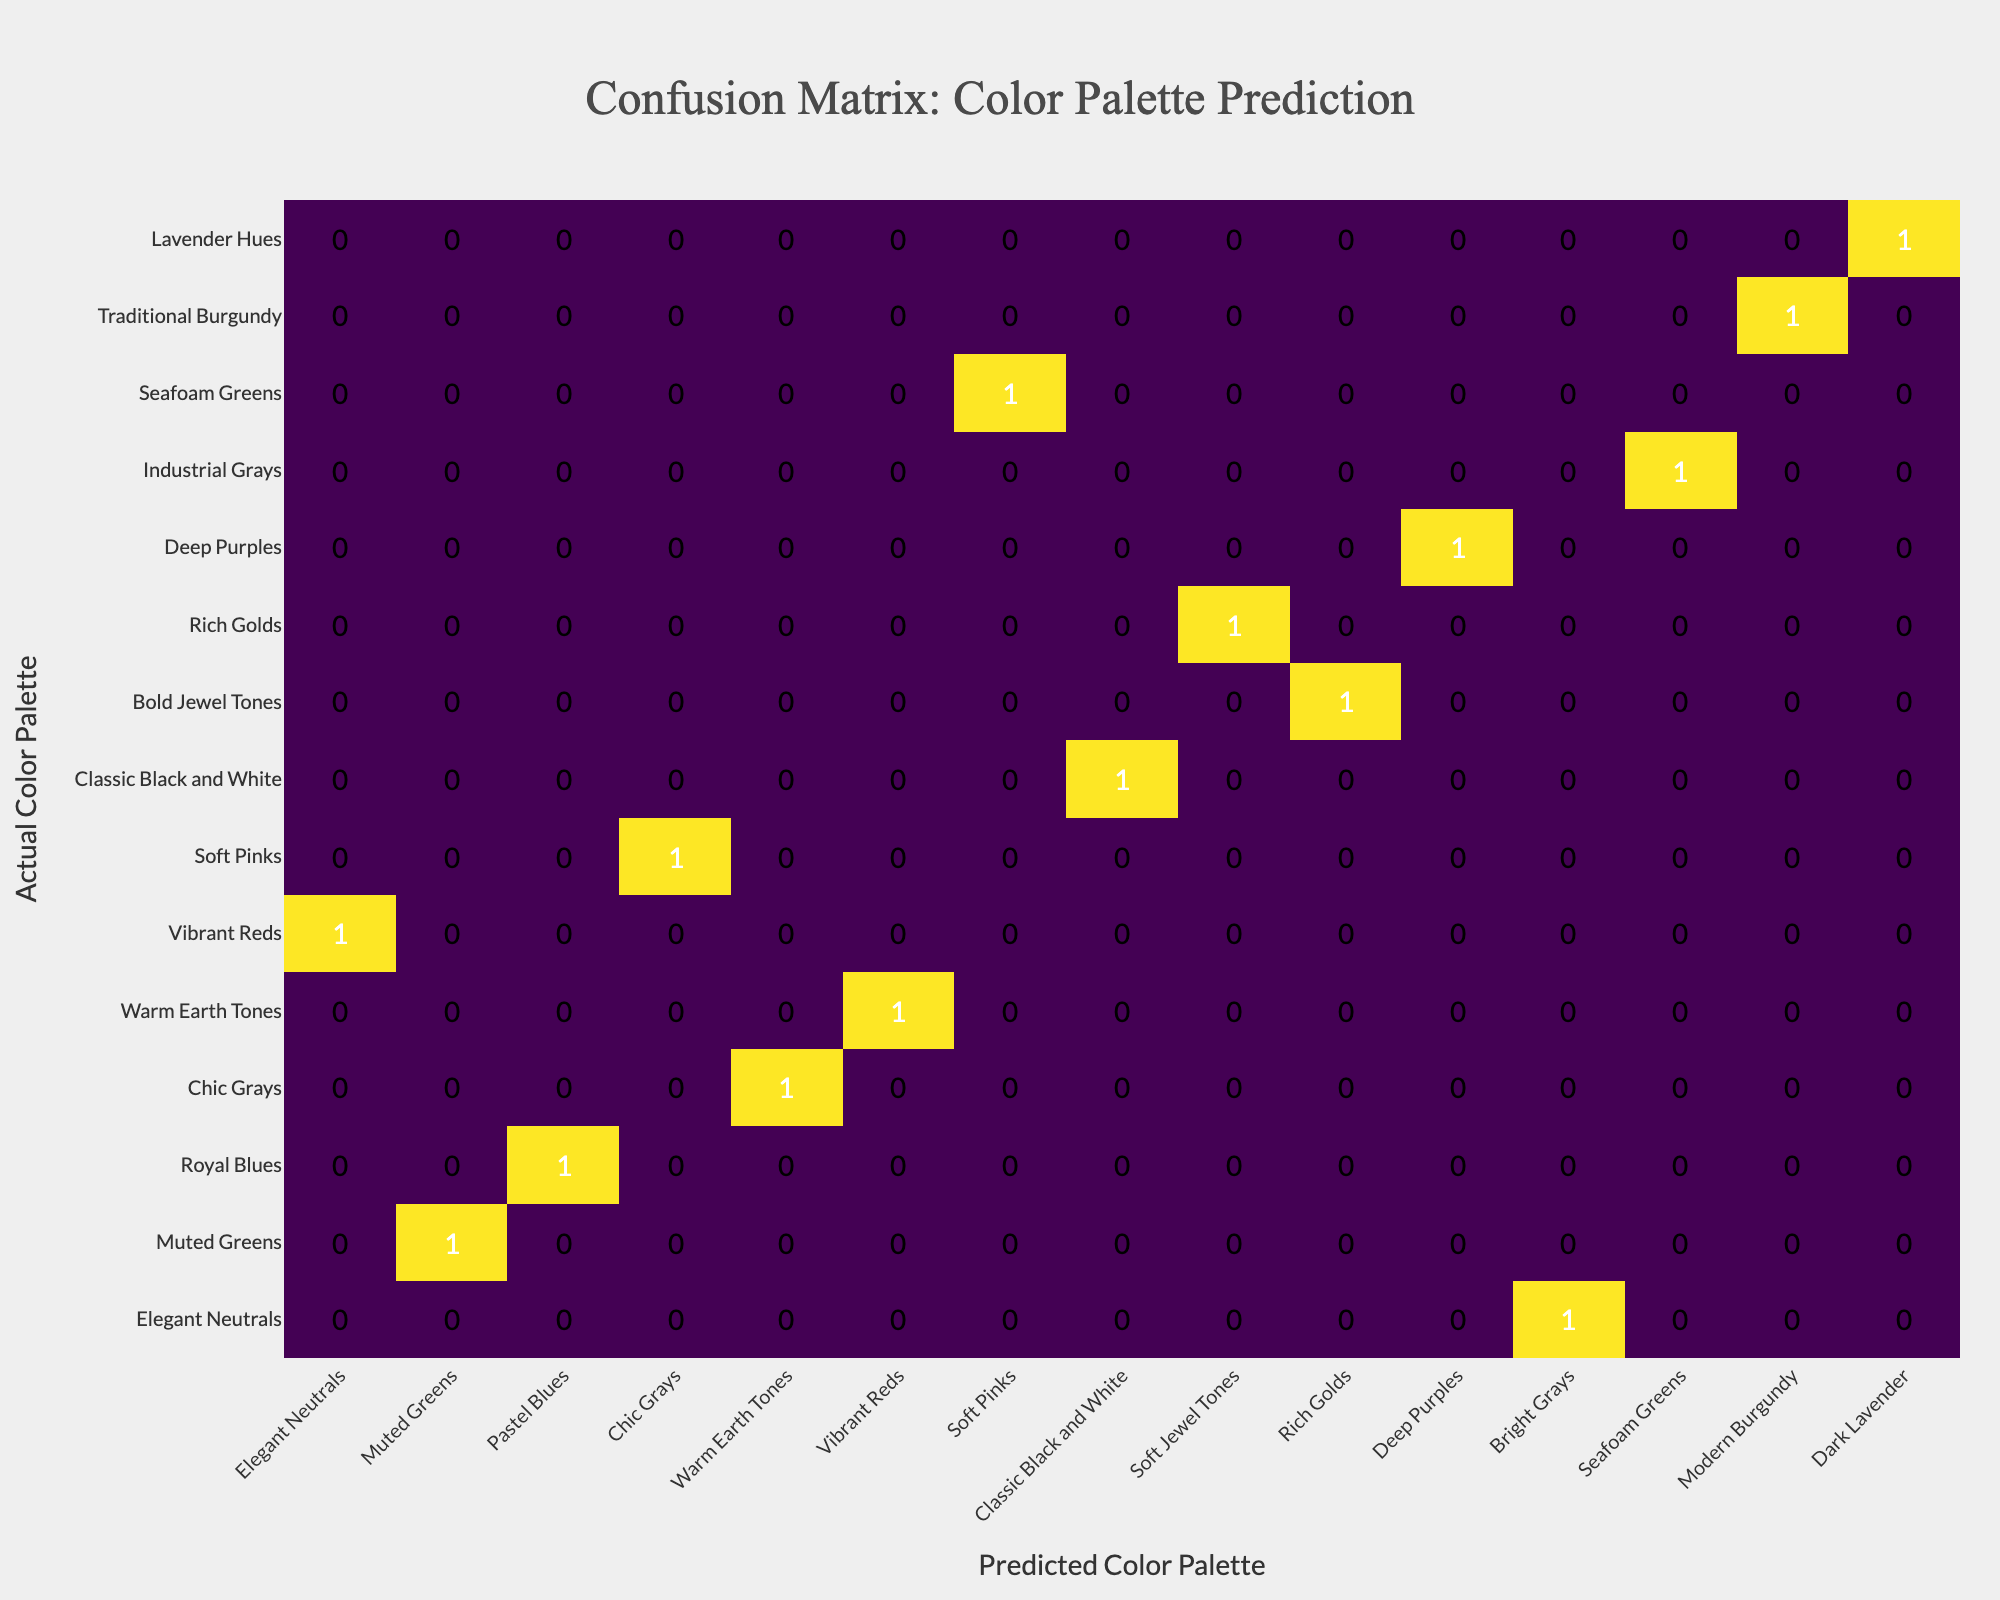What is the prediction accuracy for the "Elegant Neutrals" color palette? The "Elegant Neutrals" color palette has been predicted correctly as "Elegant Neutrals" in the table. Therefore, it is a correct prediction indicated by a true label.
Answer: True How many color palettes were predicted incorrectly? By analyzing the table, the incorrectly predicted color palettes are "Royal Blues" (wrongly predicted as Pastel Blues), "Bold Jewel Tones" (predicted as Soft Jewel Tones), "Industrial Grays" (predicted as Bright Grays), "Traditional Burgundy" (predicted as Modern Burgundy), and "Lavender Hues" (predicted as Dark Lavender). That makes a total of 5 incorrect predictions.
Answer: 5 What is the ratio of correct predictions to total predictions? There are 9 correct predictions and a total of 14 predictions. To find the ratio, divide the number of correct predictions (9) by the total predictions (14), which equals approximately 0.643. This can also be expressed as a ratio of 9:14.
Answer: 9:14 Which predicted color palette has the highest count of correct predictions? The predicted color palette that matches the actual and has no incorrect predictions includes "Elegant Neutrals," "Muted Greens," "Chic Grays," "Warm Earth Tones," "Vibrant Reds," "Soft Pinks," "Classic Black and White," "Rich Golds," and "Deep Purples." Each of these has one correct count, however, they are tied; thus, all of the mentioned palettes qualify.
Answer: All listed palettes Is "Chic Grays" an accurately predicted palette? According to the table, "Chic Grays" is correctly predicted as "Chic Grays." This directly confirms that it is an accurate prediction.
Answer: Yes Which color palette was predicted correctly that contains higher saturation? "Rich Golds" is the only palette representing a richer, more saturated hue that is accurately predicted since it is labeled true and recognized for opulence in decor. Comparing it to other hues implies it's more saturated.
Answer: Rich Golds What percentage of the total predictions are accurate? To calculate the accuracy percentage, divide the number of correct predictions (9) by the total number of predictions (14) and multiply by 100. This gives an accuracy of approximately 64.3%.
Answer: 64.3% In the case where "Deep Purples" is predicted, was the prediction correct? The table indicates "Deep Purples" is correctly predicted as "Deep Purples," meaning that the prediction was indeed accurate.
Answer: Yes 